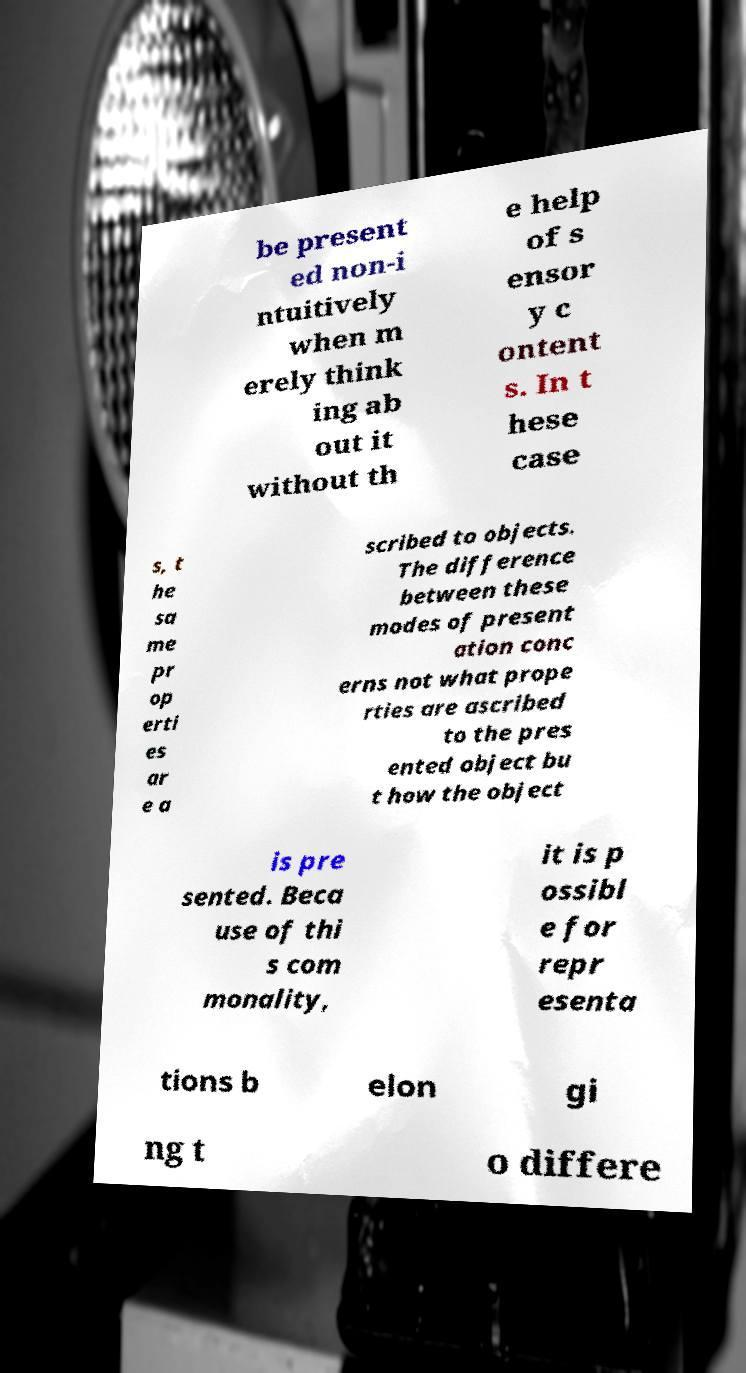What messages or text are displayed in this image? I need them in a readable, typed format. be present ed non-i ntuitively when m erely think ing ab out it without th e help of s ensor y c ontent s. In t hese case s, t he sa me pr op erti es ar e a scribed to objects. The difference between these modes of present ation conc erns not what prope rties are ascribed to the pres ented object bu t how the object is pre sented. Beca use of thi s com monality, it is p ossibl e for repr esenta tions b elon gi ng t o differe 